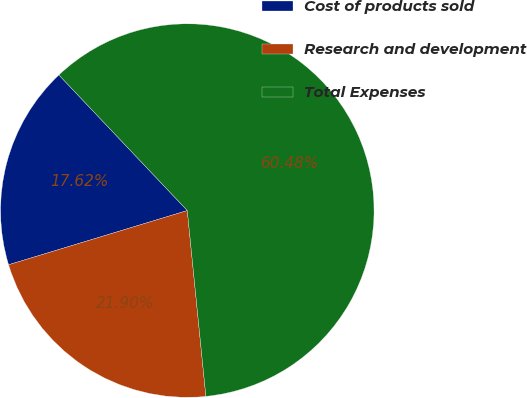<chart> <loc_0><loc_0><loc_500><loc_500><pie_chart><fcel>Cost of products sold<fcel>Research and development<fcel>Total Expenses<nl><fcel>17.62%<fcel>21.9%<fcel>60.48%<nl></chart> 